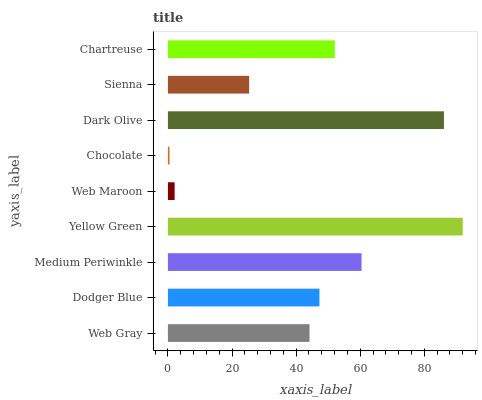Is Chocolate the minimum?
Answer yes or no. Yes. Is Yellow Green the maximum?
Answer yes or no. Yes. Is Dodger Blue the minimum?
Answer yes or no. No. Is Dodger Blue the maximum?
Answer yes or no. No. Is Dodger Blue greater than Web Gray?
Answer yes or no. Yes. Is Web Gray less than Dodger Blue?
Answer yes or no. Yes. Is Web Gray greater than Dodger Blue?
Answer yes or no. No. Is Dodger Blue less than Web Gray?
Answer yes or no. No. Is Dodger Blue the high median?
Answer yes or no. Yes. Is Dodger Blue the low median?
Answer yes or no. Yes. Is Medium Periwinkle the high median?
Answer yes or no. No. Is Medium Periwinkle the low median?
Answer yes or no. No. 